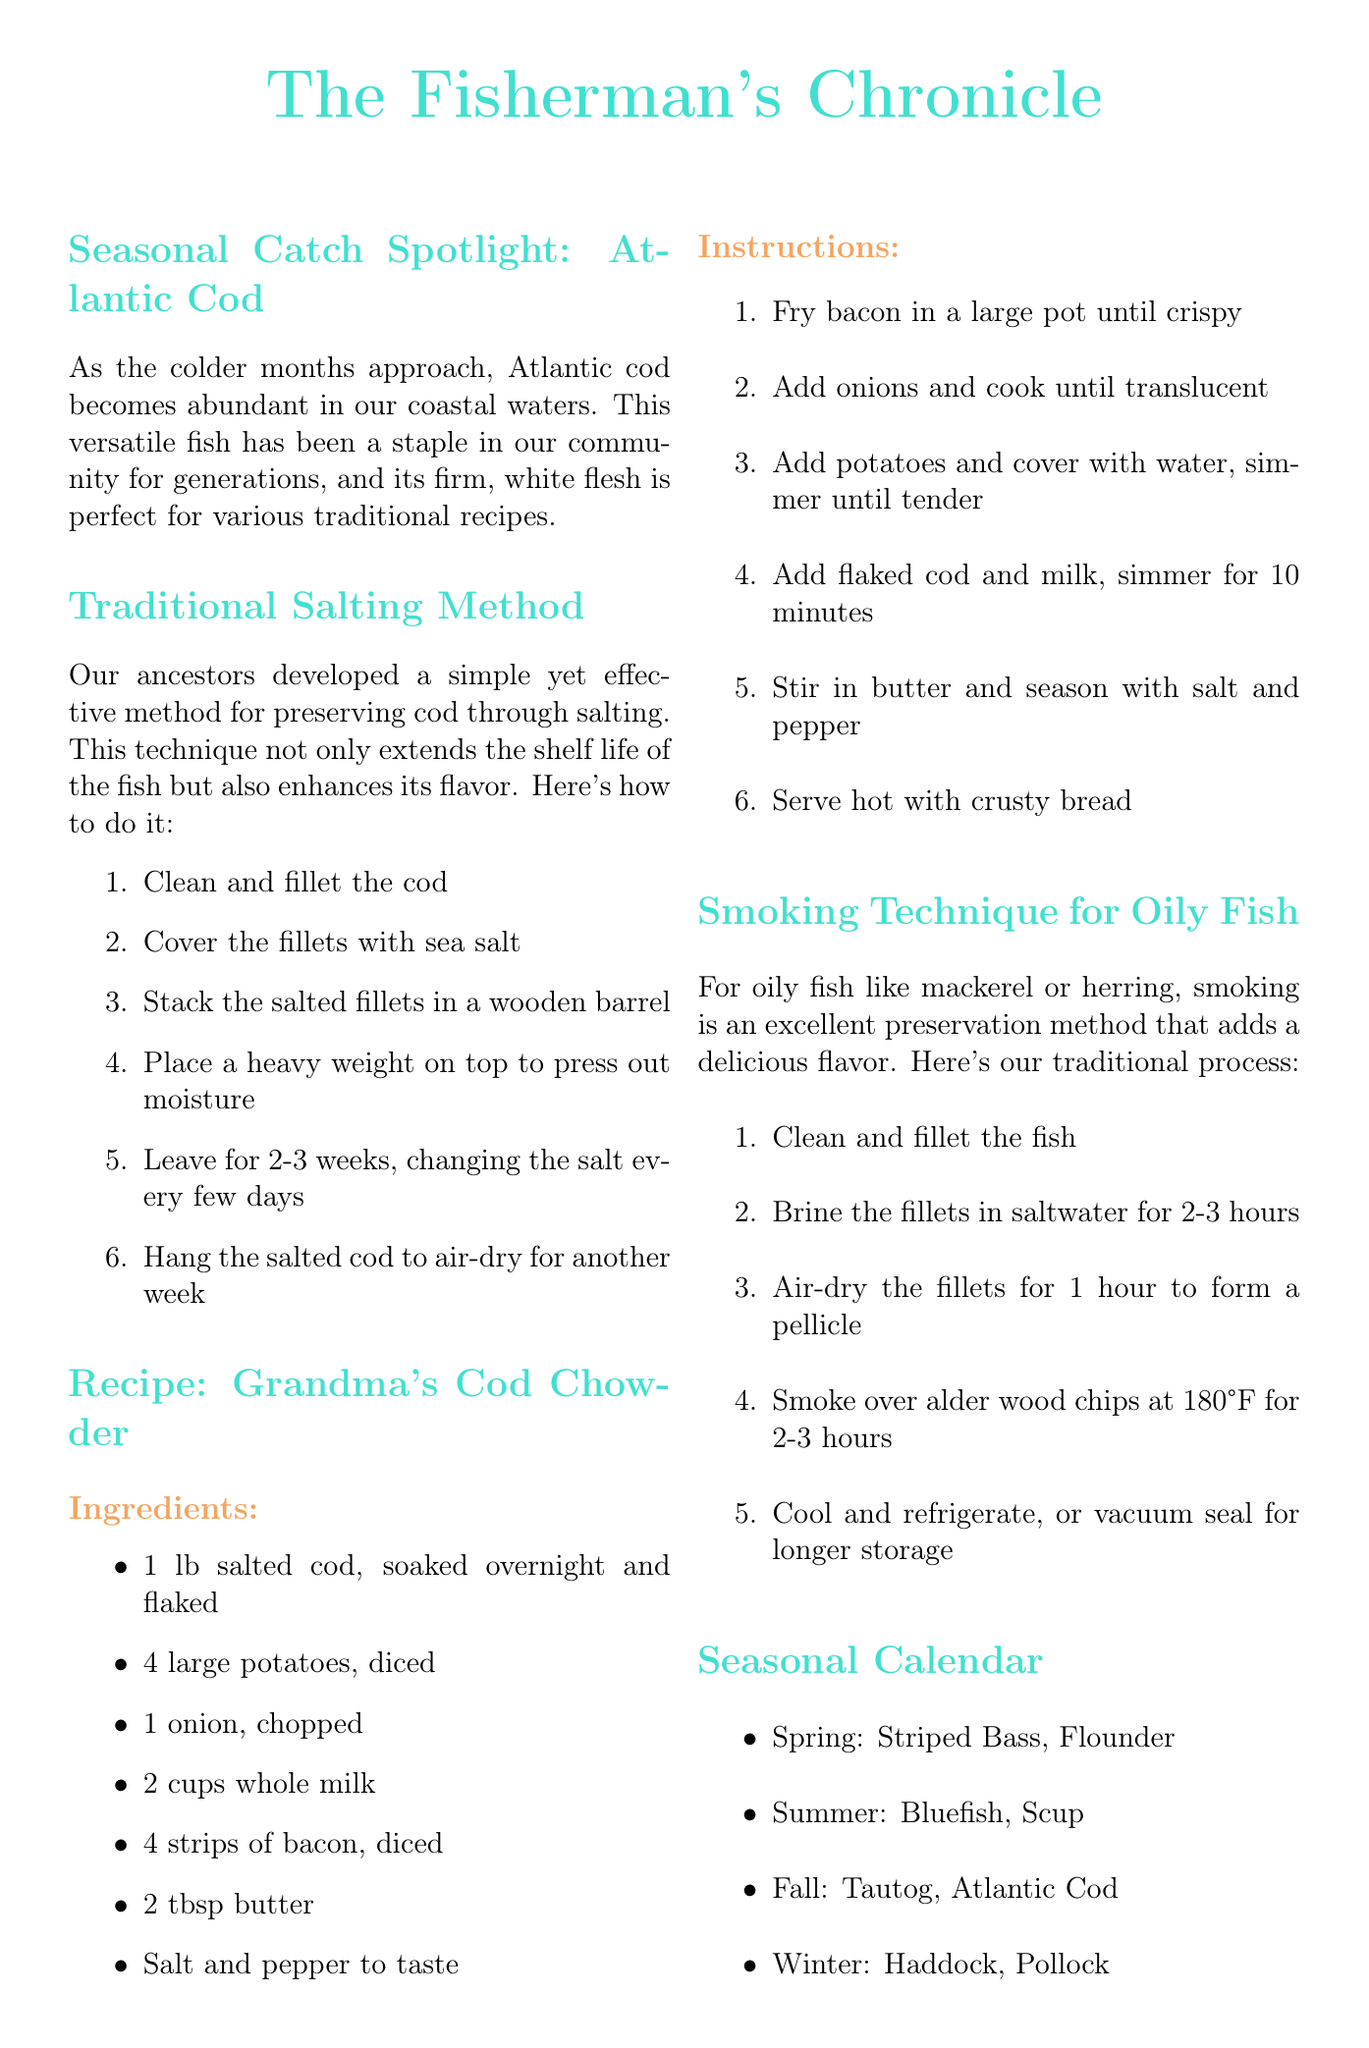What is the seasonal catch highlighted in the newsletter? The seasonal catch spotlighted is Atlantic Cod, mentioned in the first section of the newsletter.
Answer: Atlantic Cod What is the first step in the traditional salting method for preserving cod? The first step in the salting method, as outlined in the traditional salting method section, is to clean and fillet the cod.
Answer: Clean and fillet the cod How many potatoes are needed for Grandma's Cod Chowder? The ingredient list for Grandma's Cod Chowder specifies the quantity of potatoes required.
Answer: 4 large potatoes What is the brining time for fillets of oily fish in the smoking technique? The document states that the fillets should be brined in saltwater for 2-3 hours, as described in the smoking technique section.
Answer: 2-3 hours In which season is Atlantic Cod most abundant according to the seasonal calendar? The seasonal calendar indicates that Atlantic Cod is most abundant in the fall.
Answer: Fall Which cooking method is suggested for oily fish? The smoking technique is mentioned as an excellent preservation method for oily fish.
Answer: Smoking What is one of the tips for sustainable fishing provided in the newsletter? A tip for sustainable fishing is included in the last section of the newsletter, highlighting various practices.
Answer: Use circle hooks to reduce bycatch What is the final step in the traditional salting method for cod? The last step of the salting method describes hanging the salted cod to air-dry for another week, which is crucial for preservation.
Answer: Hang the salted cod to air-dry for another week 